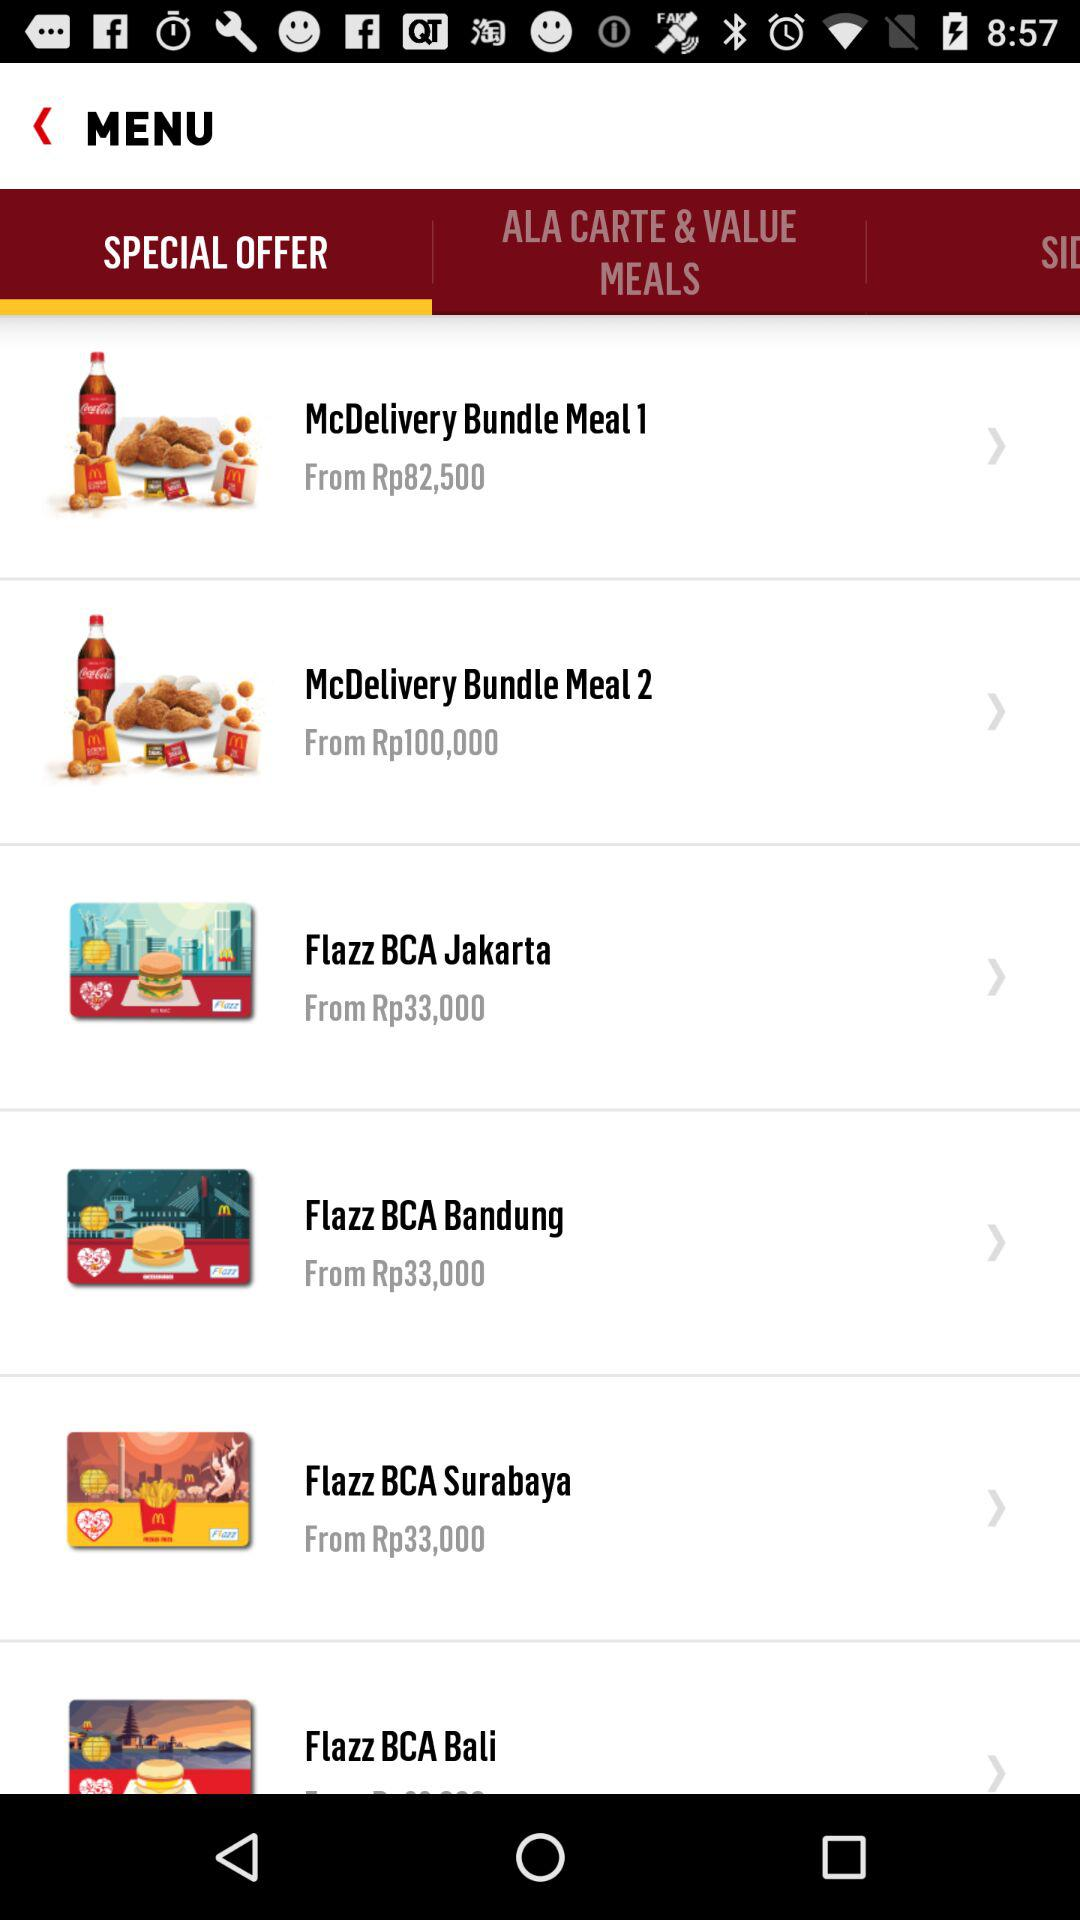How much does "Flazz BCA Bali" cost?
When the provided information is insufficient, respond with <no answer>. <no answer> 